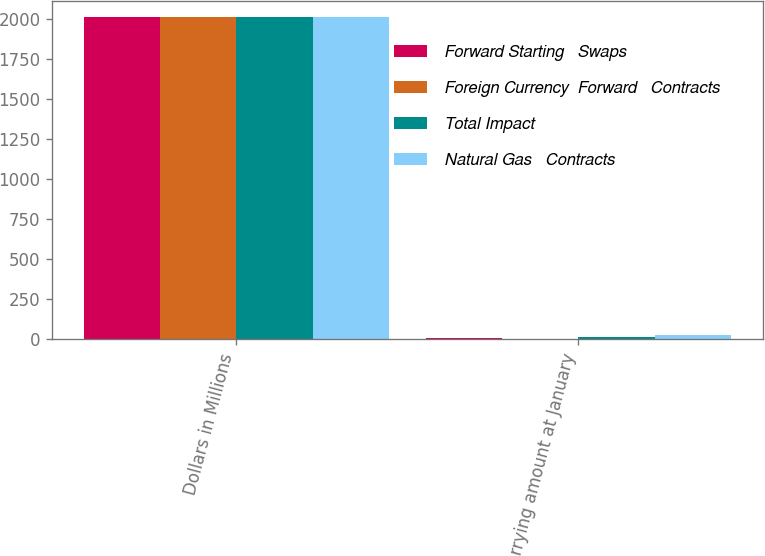Convert chart. <chart><loc_0><loc_0><loc_500><loc_500><stacked_bar_chart><ecel><fcel>Dollars in Millions<fcel>Net carrying amount at January<nl><fcel>Forward Starting   Swaps<fcel>2010<fcel>11<nl><fcel>Foreign Currency  Forward   Contracts<fcel>2010<fcel>1<nl><fcel>Total Impact<fcel>2010<fcel>18<nl><fcel>Natural Gas   Contracts<fcel>2010<fcel>30<nl></chart> 